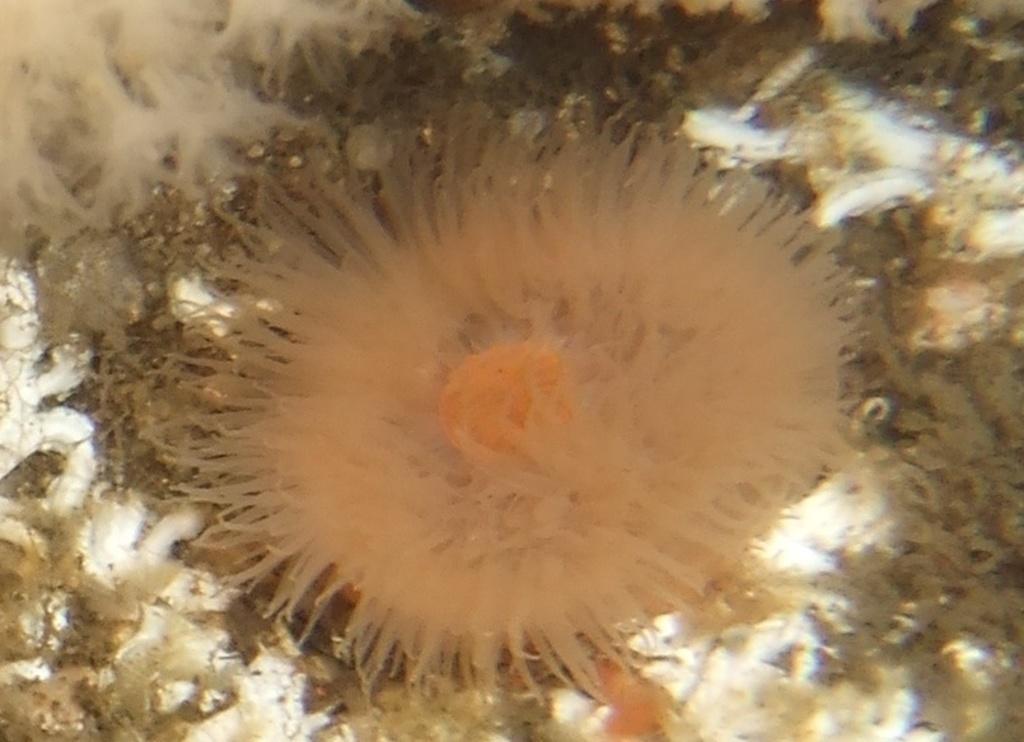Please provide a concise description of this image. This picture is consists of marine biology. 